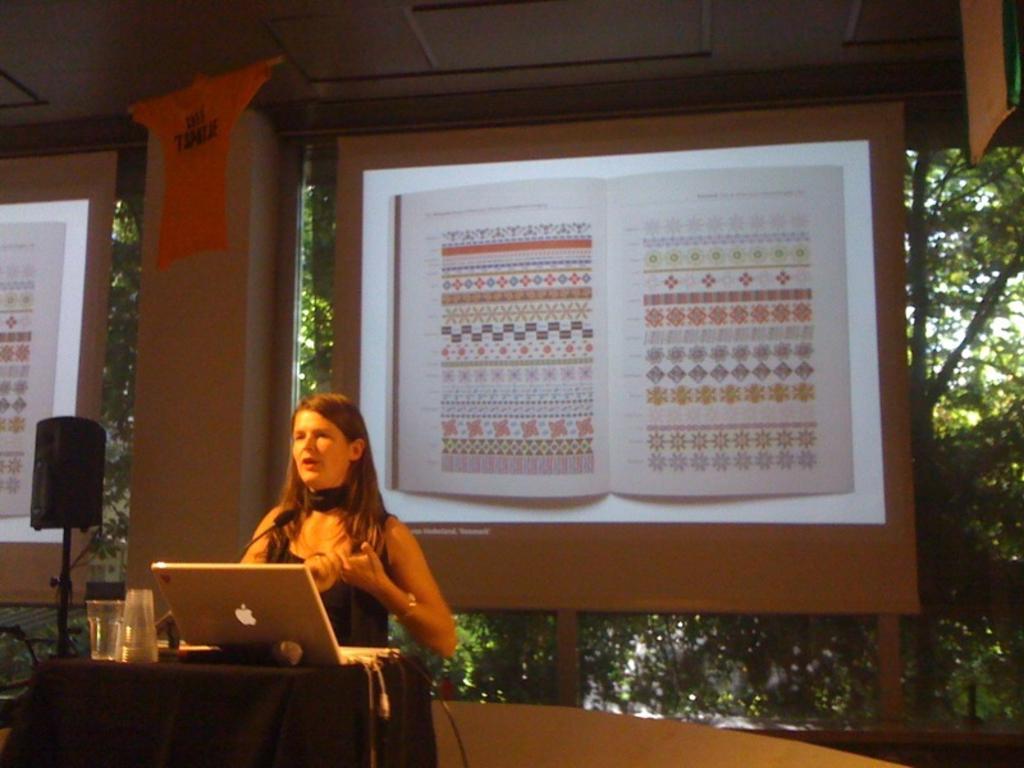How would you summarize this image in a sentence or two? In this picture there is a lady who is standing on the stage before a table, there is a glass and laptop on the table, there is a speaker at the left side of the image and there is a projector screen on the center of the image with a printed book post. 